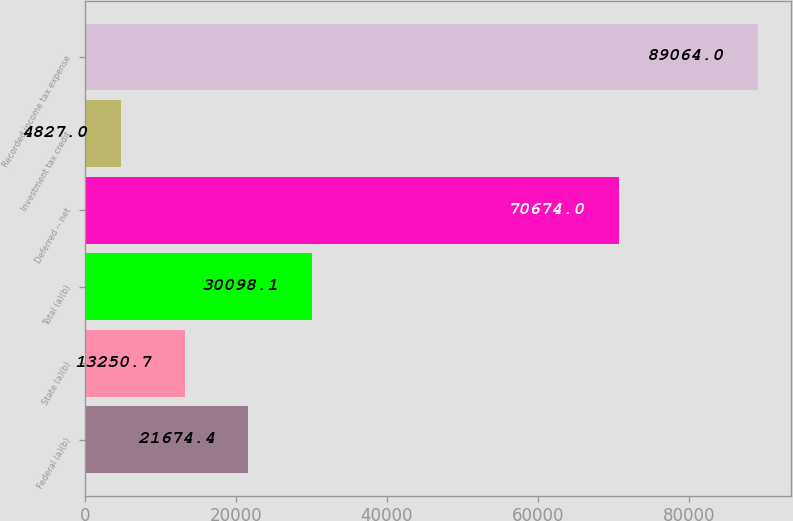Convert chart. <chart><loc_0><loc_0><loc_500><loc_500><bar_chart><fcel>Federal (a)(b)<fcel>State (a)(b)<fcel>Total (a)(b)<fcel>Deferred -- net<fcel>Investment tax credit<fcel>Recorded income tax expense<nl><fcel>21674.4<fcel>13250.7<fcel>30098.1<fcel>70674<fcel>4827<fcel>89064<nl></chart> 